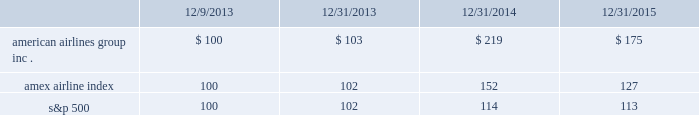Table of contents capital deployment program will be subject to market and economic conditions , applicable legal requirements and other relevant factors .
Our capital deployment program does not obligate us to continue a dividend for any fixed period , and payment of dividends may be suspended at any time at our discretion .
Stock performance graph the following stock performance graph and related information shall not be deemed 201csoliciting material 201d or 201cfiled 201d with the securities and exchange commission , nor shall such information be incorporated by reference into any future filings under the securities act of 1933 or the exchange act , each as amended , except to the extent that we specifically incorporate it by reference into such filing .
The following stock performance graph compares our cumulative total stockholder return on an annual basis on our common stock with the cumulative total return on the standard and poor 2019s 500 stock index and the amex airline index from december 9 , 2013 ( the first trading day of aag common stock ) through december 31 , 2015 .
The comparison assumes $ 100 was invested on december 9 , 2013 in aag common stock and in each of the foregoing indices and assumes reinvestment of dividends .
The stock performance shown on the graph below represents historical stock performance and is not necessarily indicative of future stock price performance. .
Purchases of equity securities by the issuer and affiliated purchasers since july 2014 , our board of directors has approved several share repurchase programs aggregating $ 7.0 billion of authority of which , as of december 31 , 2015 , $ 2.4 billion remained unused under repurchase programs .
What was the 4 year return of american airlines group inc . common stock? 
Computations: ((175 - 100) / 100)
Answer: 0.75. 